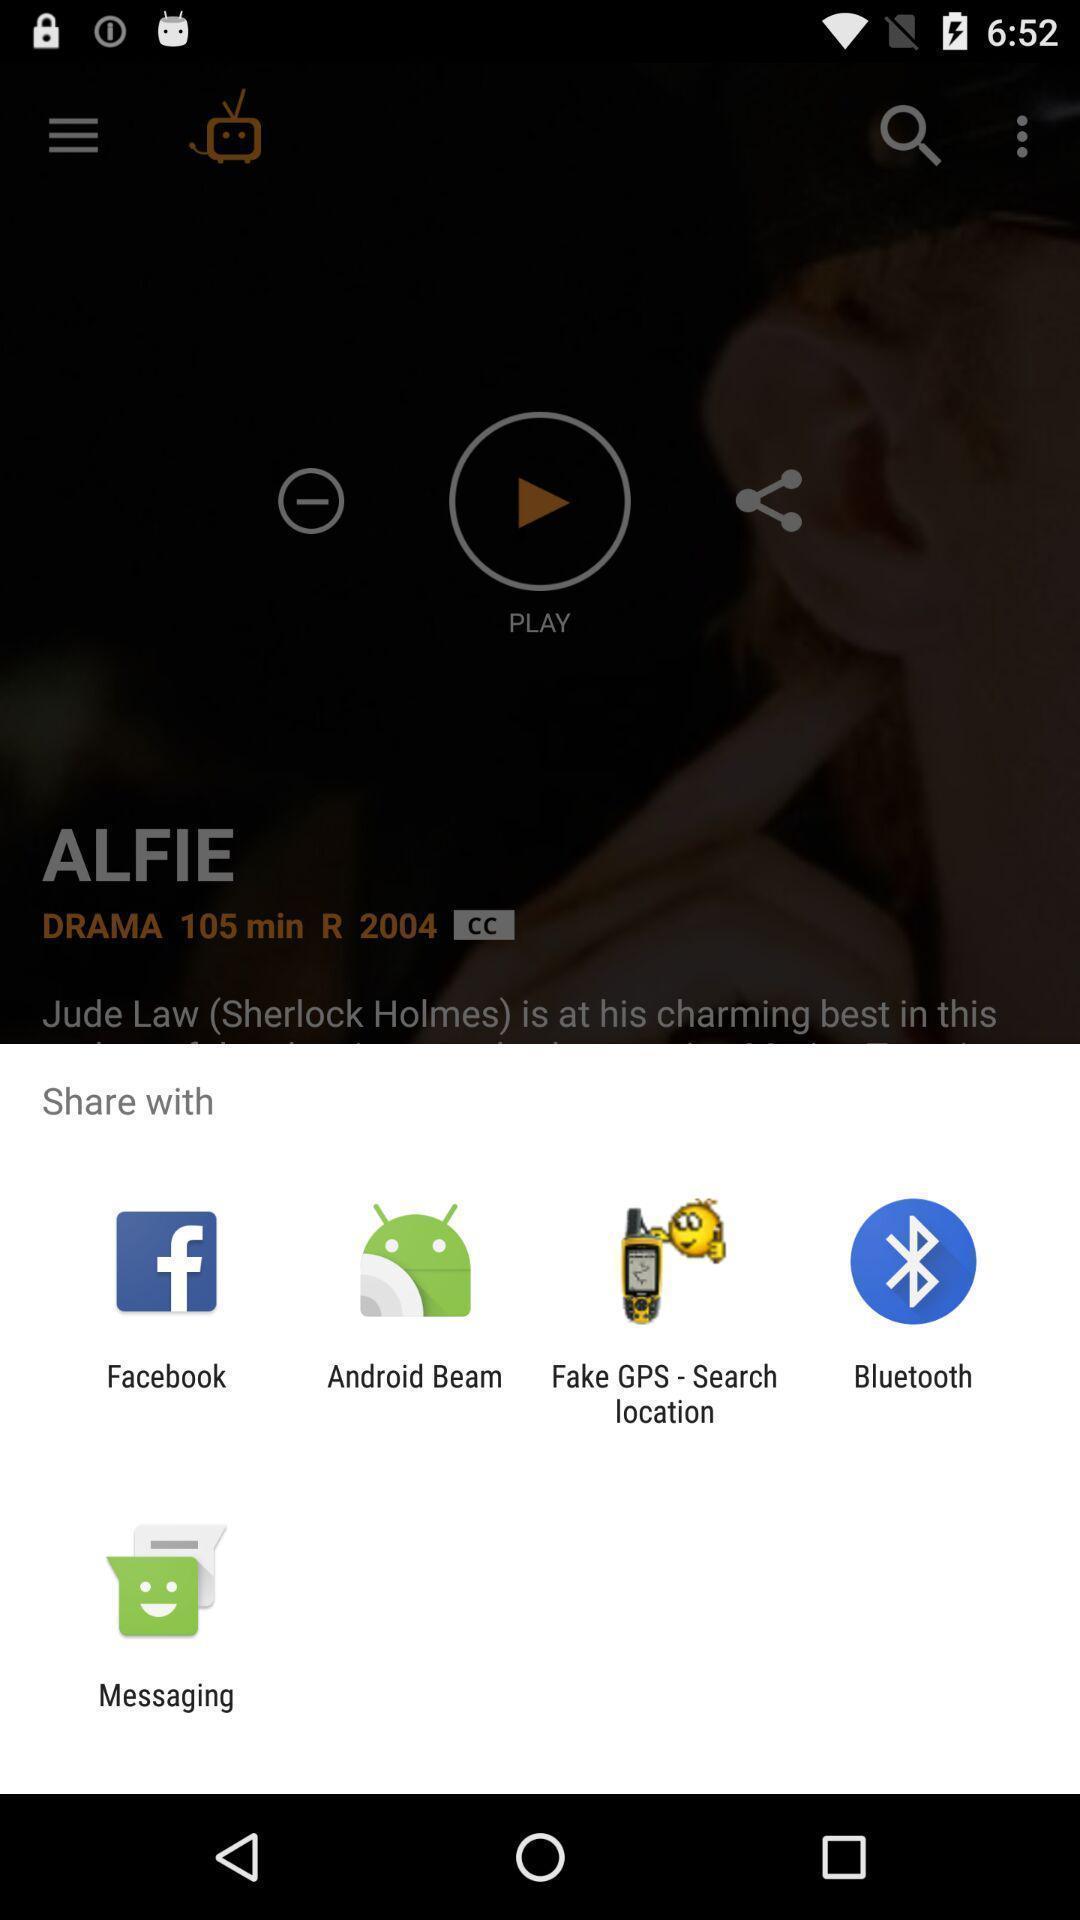Tell me about the visual elements in this screen capture. Popup to share in the video streaming app. 